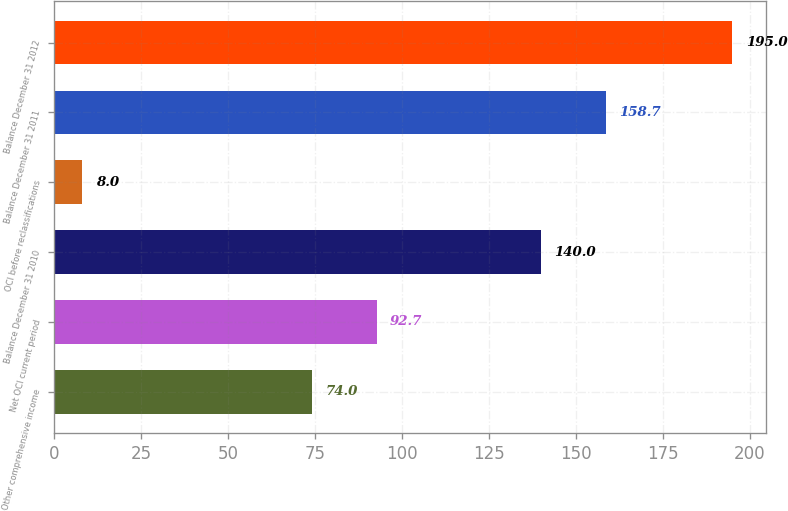Convert chart. <chart><loc_0><loc_0><loc_500><loc_500><bar_chart><fcel>Other comprehensive income<fcel>Net OCI current period<fcel>Balance December 31 2010<fcel>OCI before reclassifications<fcel>Balance December 31 2011<fcel>Balance December 31 2012<nl><fcel>74<fcel>92.7<fcel>140<fcel>8<fcel>158.7<fcel>195<nl></chart> 